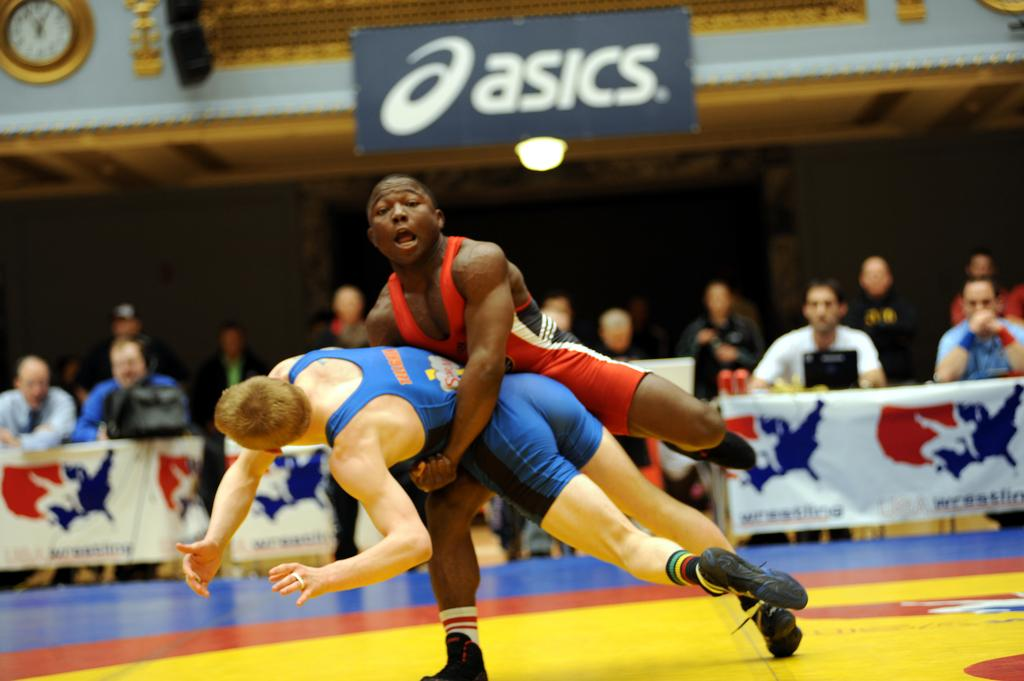<image>
Provide a brief description of the given image. Two wrestlers one in blue and the other in red are about to go to the floor under the Asics banner. 